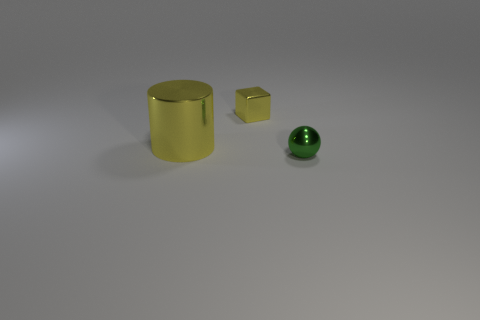Add 1 small green metallic objects. How many objects exist? 4 Subtract all cylinders. How many objects are left? 2 Add 2 big yellow things. How many big yellow things are left? 3 Add 2 red cubes. How many red cubes exist? 2 Subtract 0 yellow spheres. How many objects are left? 3 Subtract all green metallic things. Subtract all green objects. How many objects are left? 1 